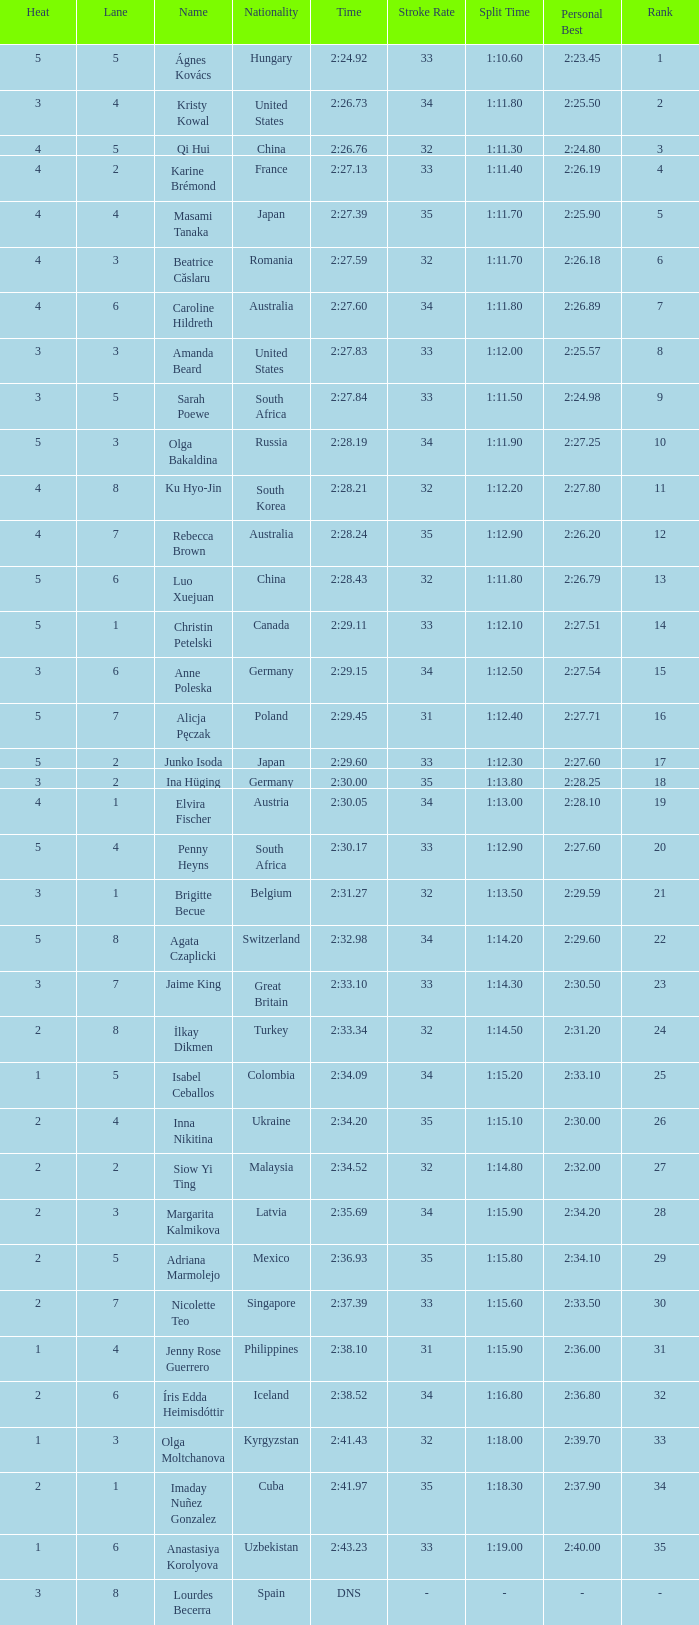What lane did inna nikitina have? 4.0. 